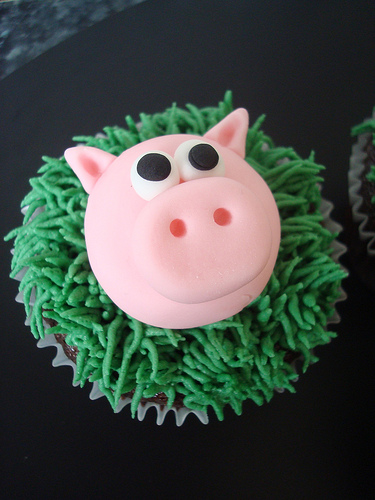<image>
Is the pig on the cupcake? Yes. Looking at the image, I can see the pig is positioned on top of the cupcake, with the cupcake providing support. 